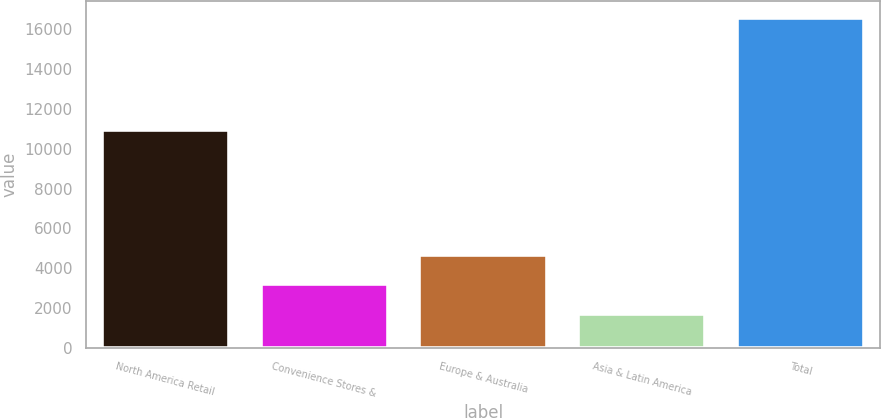Convert chart. <chart><loc_0><loc_0><loc_500><loc_500><bar_chart><fcel>North America Retail<fcel>Convenience Stores &<fcel>Europe & Australia<fcel>Asia & Latin America<fcel>Total<nl><fcel>10936.6<fcel>3190.54<fcel>4676.38<fcel>1704.7<fcel>16563.1<nl></chart> 